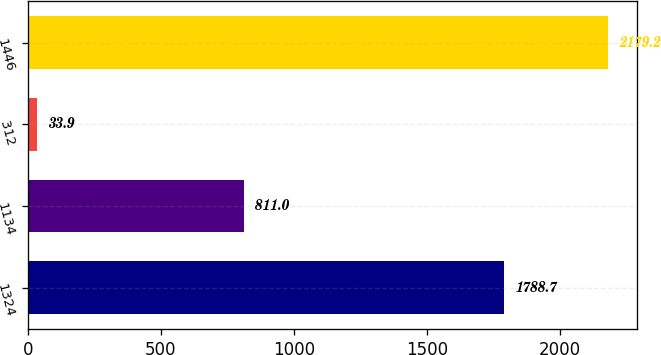<chart> <loc_0><loc_0><loc_500><loc_500><bar_chart><fcel>1324<fcel>1134<fcel>312<fcel>1446<nl><fcel>1788.7<fcel>811<fcel>33.9<fcel>2179.2<nl></chart> 